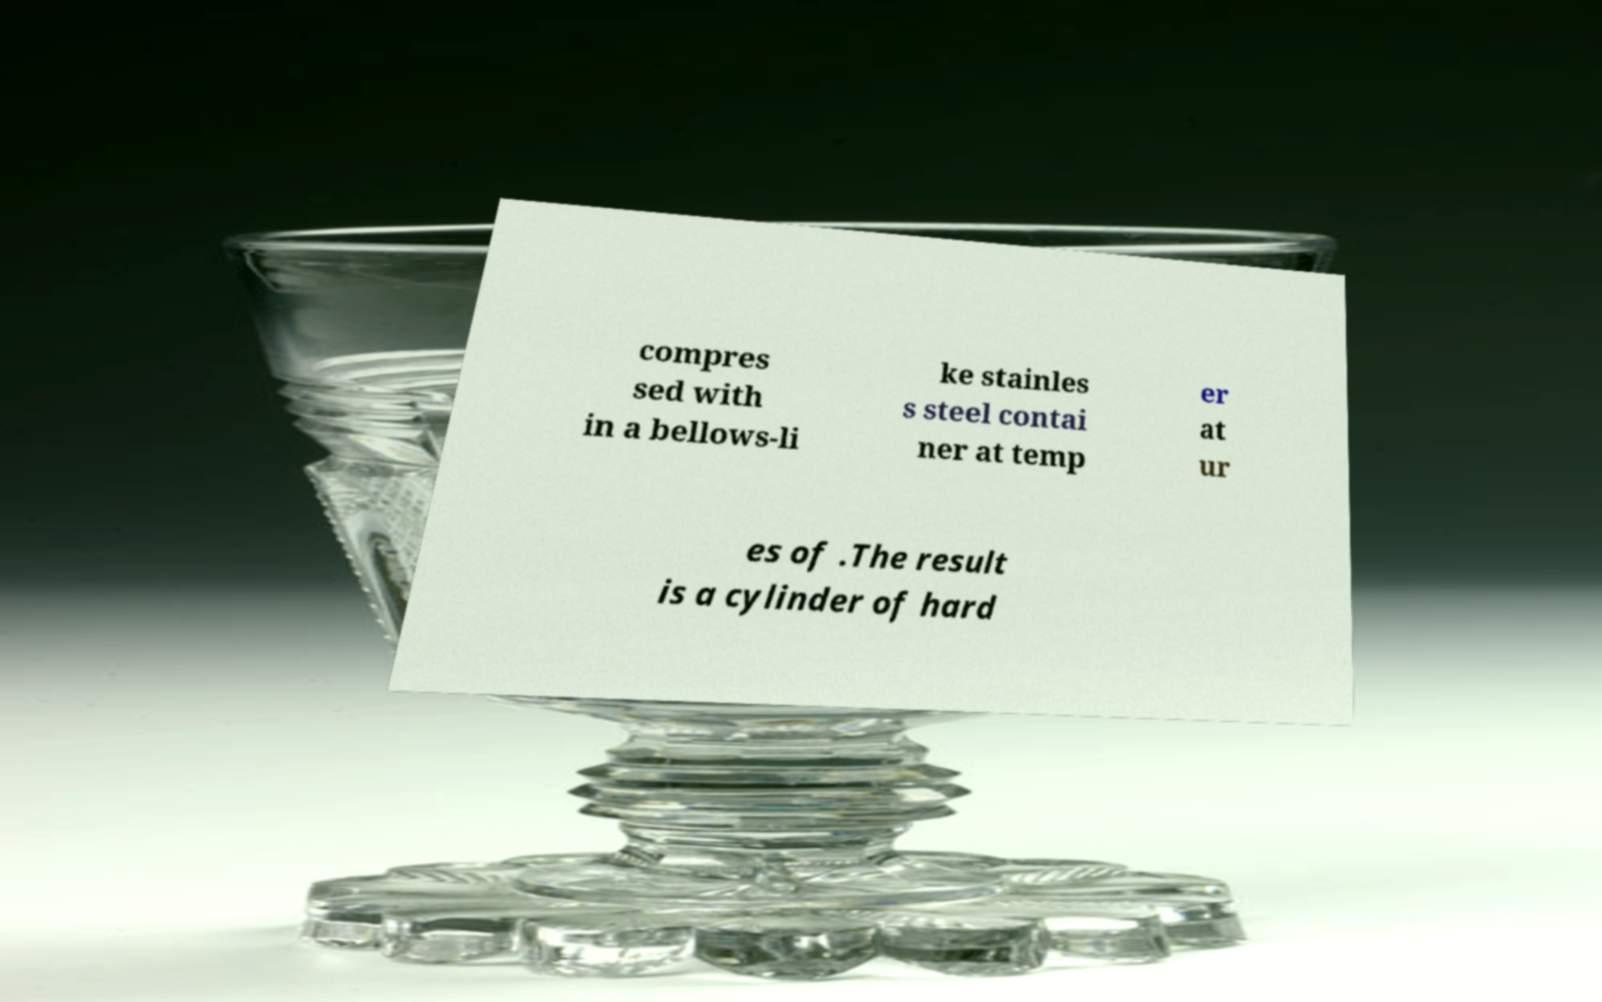There's text embedded in this image that I need extracted. Can you transcribe it verbatim? compres sed with in a bellows-li ke stainles s steel contai ner at temp er at ur es of .The result is a cylinder of hard 